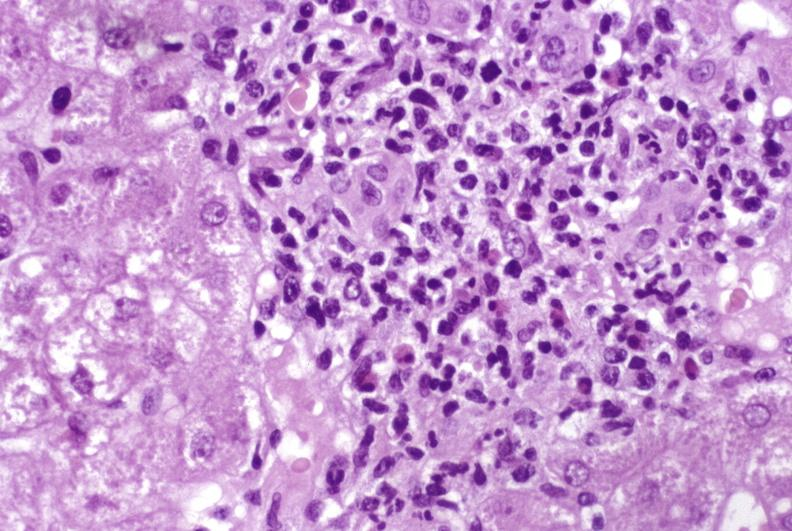what is present?
Answer the question using a single word or phrase. Liver 